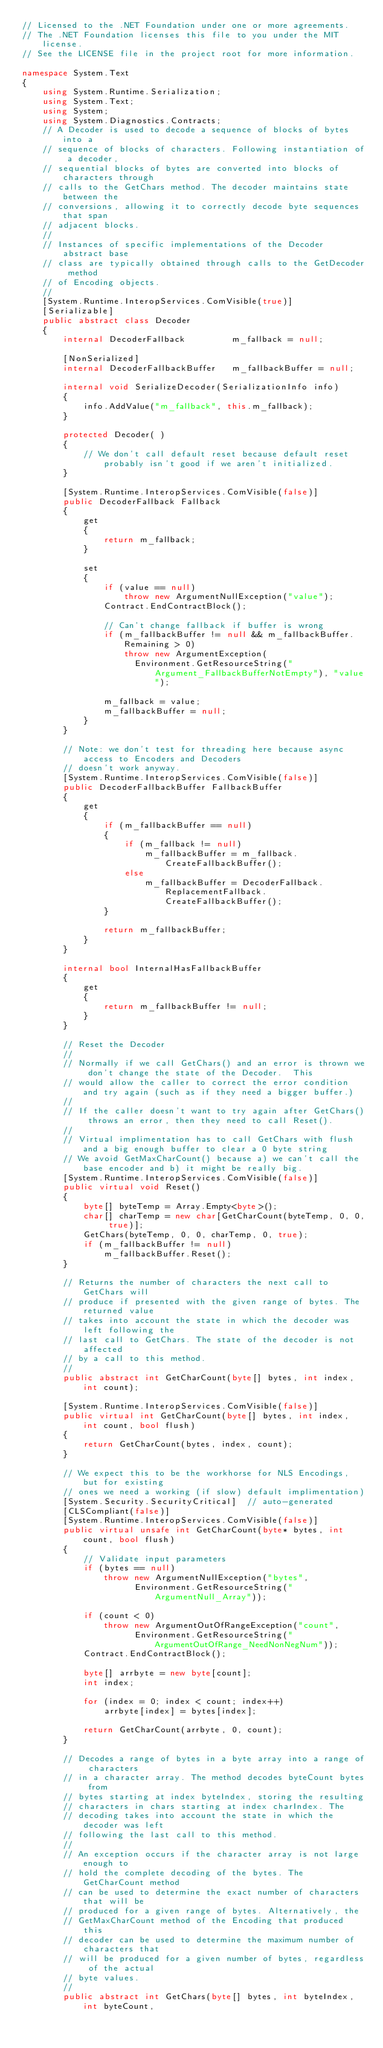<code> <loc_0><loc_0><loc_500><loc_500><_C#_>// Licensed to the .NET Foundation under one or more agreements.
// The .NET Foundation licenses this file to you under the MIT license.
// See the LICENSE file in the project root for more information.

namespace System.Text
{
    using System.Runtime.Serialization;
    using System.Text;
    using System;
    using System.Diagnostics.Contracts;
    // A Decoder is used to decode a sequence of blocks of bytes into a
    // sequence of blocks of characters. Following instantiation of a decoder,
    // sequential blocks of bytes are converted into blocks of characters through
    // calls to the GetChars method. The decoder maintains state between the
    // conversions, allowing it to correctly decode byte sequences that span
    // adjacent blocks.
    //
    // Instances of specific implementations of the Decoder abstract base
    // class are typically obtained through calls to the GetDecoder method
    // of Encoding objects.
    //
    [System.Runtime.InteropServices.ComVisible(true)]
    [Serializable]
    public abstract class Decoder
    {
        internal DecoderFallback         m_fallback = null;

        [NonSerialized]
        internal DecoderFallbackBuffer   m_fallbackBuffer = null;

        internal void SerializeDecoder(SerializationInfo info)
        {
            info.AddValue("m_fallback", this.m_fallback);
        }

        protected Decoder( )
        {
            // We don't call default reset because default reset probably isn't good if we aren't initialized.
        }

        [System.Runtime.InteropServices.ComVisible(false)]
        public DecoderFallback Fallback
        {
            get
            {
                return m_fallback;
            }

            set
            {
                if (value == null)
                    throw new ArgumentNullException("value");
                Contract.EndContractBlock();

                // Can't change fallback if buffer is wrong
                if (m_fallbackBuffer != null && m_fallbackBuffer.Remaining > 0)
                    throw new ArgumentException(
                      Environment.GetResourceString("Argument_FallbackBufferNotEmpty"), "value");

                m_fallback = value;
                m_fallbackBuffer = null;
            }
        }

        // Note: we don't test for threading here because async access to Encoders and Decoders
        // doesn't work anyway.
        [System.Runtime.InteropServices.ComVisible(false)]
        public DecoderFallbackBuffer FallbackBuffer
        {
            get
            {
                if (m_fallbackBuffer == null)
                {
                    if (m_fallback != null)
                        m_fallbackBuffer = m_fallback.CreateFallbackBuffer();
                    else
                        m_fallbackBuffer = DecoderFallback.ReplacementFallback.CreateFallbackBuffer();
                }

                return m_fallbackBuffer;
            }
        }

        internal bool InternalHasFallbackBuffer
        {
            get
            {
                return m_fallbackBuffer != null;
            }
        }

        // Reset the Decoder
        //
        // Normally if we call GetChars() and an error is thrown we don't change the state of the Decoder.  This
        // would allow the caller to correct the error condition and try again (such as if they need a bigger buffer.)
        //
        // If the caller doesn't want to try again after GetChars() throws an error, then they need to call Reset().
        //
        // Virtual implimentation has to call GetChars with flush and a big enough buffer to clear a 0 byte string
        // We avoid GetMaxCharCount() because a) we can't call the base encoder and b) it might be really big.
        [System.Runtime.InteropServices.ComVisible(false)]
        public virtual void Reset()
        {
            byte[] byteTemp = Array.Empty<byte>();
            char[] charTemp = new char[GetCharCount(byteTemp, 0, 0, true)];
            GetChars(byteTemp, 0, 0, charTemp, 0, true);
            if (m_fallbackBuffer != null)
                m_fallbackBuffer.Reset();
        }

        // Returns the number of characters the next call to GetChars will
        // produce if presented with the given range of bytes. The returned value
        // takes into account the state in which the decoder was left following the
        // last call to GetChars. The state of the decoder is not affected
        // by a call to this method.
        //
        public abstract int GetCharCount(byte[] bytes, int index, int count);

        [System.Runtime.InteropServices.ComVisible(false)]
        public virtual int GetCharCount(byte[] bytes, int index, int count, bool flush)
        {
            return GetCharCount(bytes, index, count);
        }

        // We expect this to be the workhorse for NLS Encodings, but for existing
        // ones we need a working (if slow) default implimentation)
        [System.Security.SecurityCritical]  // auto-generated
        [CLSCompliant(false)]
        [System.Runtime.InteropServices.ComVisible(false)]
        public virtual unsafe int GetCharCount(byte* bytes, int count, bool flush)
        {
            // Validate input parameters
            if (bytes == null)
                throw new ArgumentNullException("bytes",
                      Environment.GetResourceString("ArgumentNull_Array"));

            if (count < 0)
                throw new ArgumentOutOfRangeException("count",
                      Environment.GetResourceString("ArgumentOutOfRange_NeedNonNegNum"));
            Contract.EndContractBlock();

            byte[] arrbyte = new byte[count];
            int index;

            for (index = 0; index < count; index++)
                arrbyte[index] = bytes[index];

            return GetCharCount(arrbyte, 0, count);
        }

        // Decodes a range of bytes in a byte array into a range of characters
        // in a character array. The method decodes byteCount bytes from
        // bytes starting at index byteIndex, storing the resulting
        // characters in chars starting at index charIndex. The
        // decoding takes into account the state in which the decoder was left
        // following the last call to this method.
        //
        // An exception occurs if the character array is not large enough to
        // hold the complete decoding of the bytes. The GetCharCount method
        // can be used to determine the exact number of characters that will be
        // produced for a given range of bytes. Alternatively, the
        // GetMaxCharCount method of the Encoding that produced this
        // decoder can be used to determine the maximum number of characters that
        // will be produced for a given number of bytes, regardless of the actual
        // byte values.
        //
        public abstract int GetChars(byte[] bytes, int byteIndex, int byteCount,</code> 